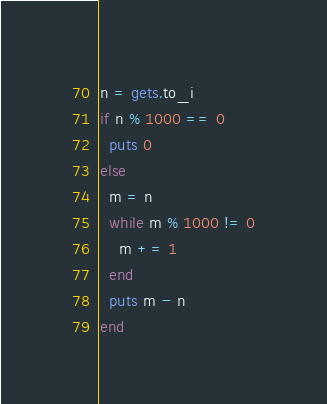Convert code to text. <code><loc_0><loc_0><loc_500><loc_500><_Ruby_>n = gets.to_i
if n % 1000 == 0
  puts 0
else
  m = n
  while m % 1000 != 0
    m += 1
  end
  puts m - n
end</code> 